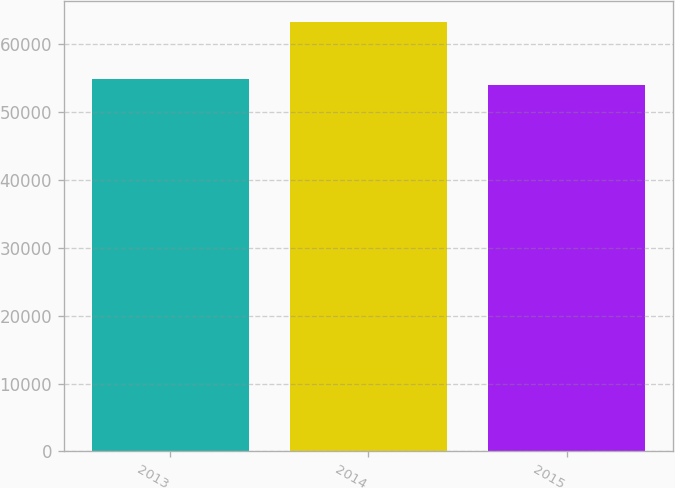Convert chart to OTSL. <chart><loc_0><loc_0><loc_500><loc_500><bar_chart><fcel>2013<fcel>2014<fcel>2015<nl><fcel>54980<fcel>63278<fcel>54006<nl></chart> 